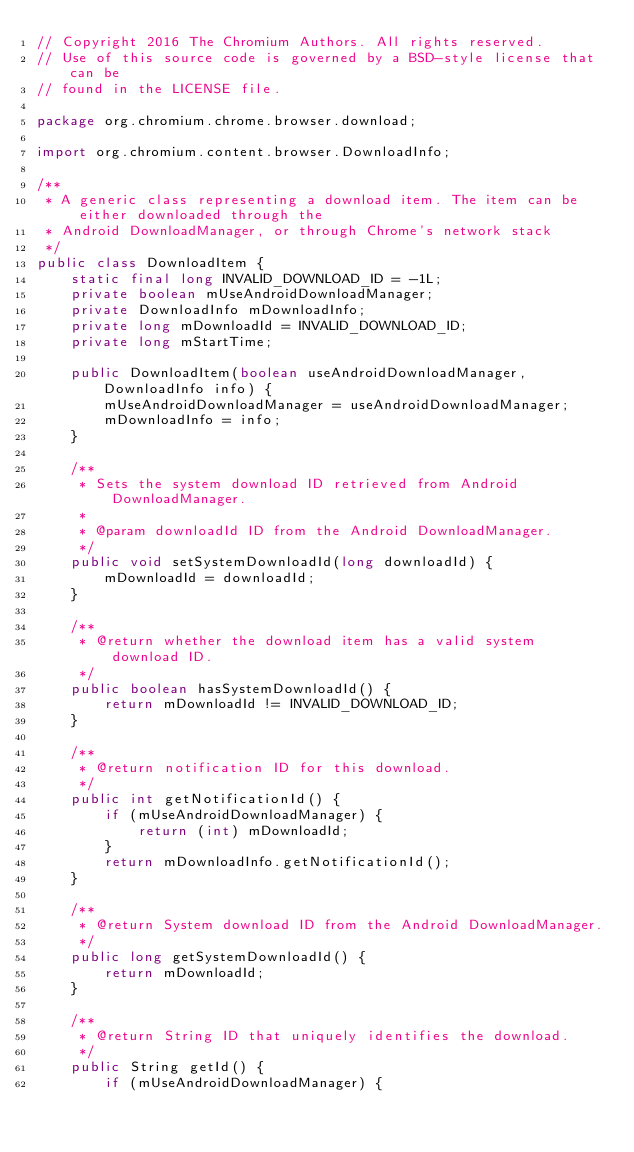<code> <loc_0><loc_0><loc_500><loc_500><_Java_>// Copyright 2016 The Chromium Authors. All rights reserved.
// Use of this source code is governed by a BSD-style license that can be
// found in the LICENSE file.

package org.chromium.chrome.browser.download;

import org.chromium.content.browser.DownloadInfo;

/**
 * A generic class representing a download item. The item can be either downloaded through the
 * Android DownloadManager, or through Chrome's network stack
 */
public class DownloadItem {
    static final long INVALID_DOWNLOAD_ID = -1L;
    private boolean mUseAndroidDownloadManager;
    private DownloadInfo mDownloadInfo;
    private long mDownloadId = INVALID_DOWNLOAD_ID;
    private long mStartTime;

    public DownloadItem(boolean useAndroidDownloadManager, DownloadInfo info) {
        mUseAndroidDownloadManager = useAndroidDownloadManager;
        mDownloadInfo = info;
    }

    /**
     * Sets the system download ID retrieved from Android DownloadManager.
     *
     * @param downloadId ID from the Android DownloadManager.
     */
    public void setSystemDownloadId(long downloadId) {
        mDownloadId = downloadId;
    }

    /**
     * @return whether the download item has a valid system download ID.
     */
    public boolean hasSystemDownloadId() {
        return mDownloadId != INVALID_DOWNLOAD_ID;
    }

    /**
     * @return notification ID for this download.
     */
    public int getNotificationId() {
        if (mUseAndroidDownloadManager) {
            return (int) mDownloadId;
        }
        return mDownloadInfo.getNotificationId();
    }

    /**
     * @return System download ID from the Android DownloadManager.
     */
    public long getSystemDownloadId() {
        return mDownloadId;
    }

    /**
     * @return String ID that uniquely identifies the download.
     */
    public String getId() {
        if (mUseAndroidDownloadManager) {</code> 